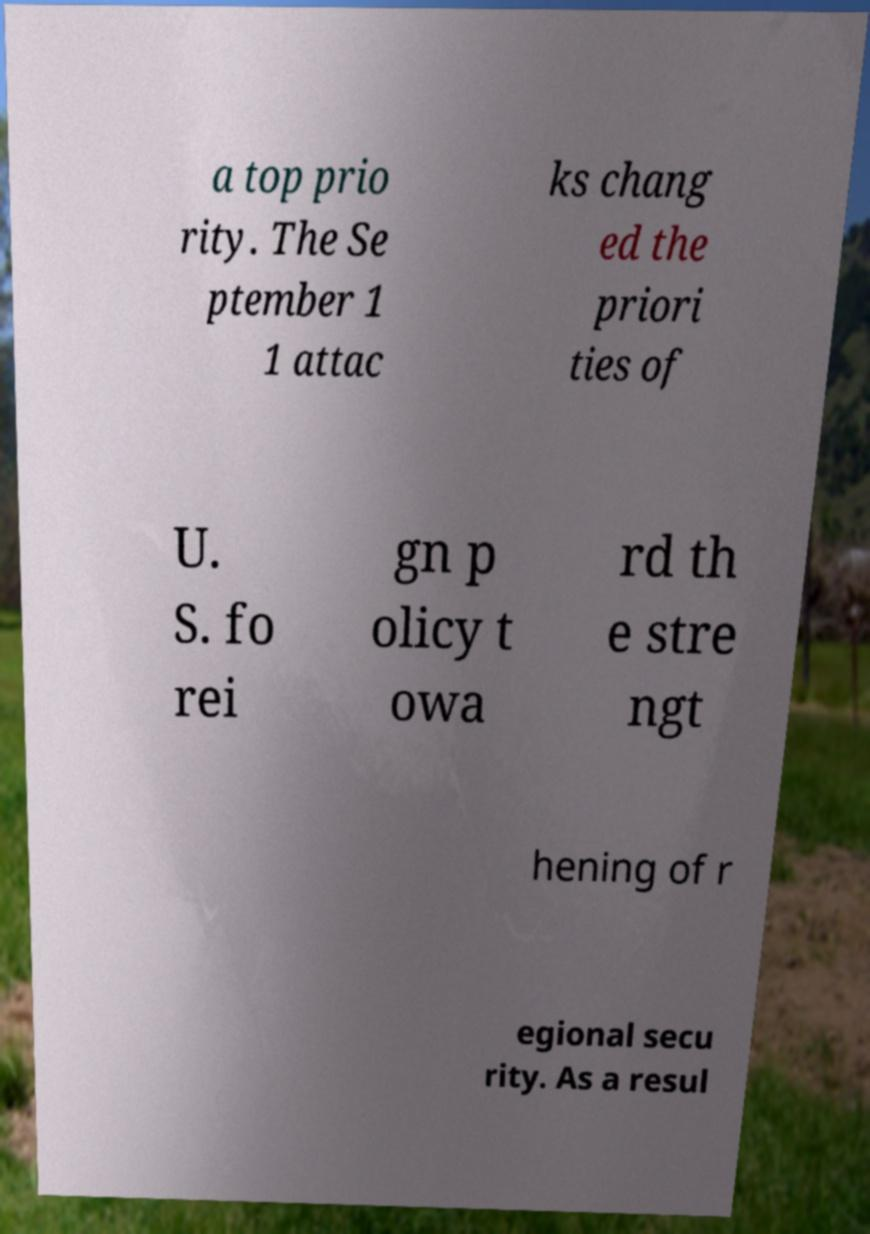Can you read and provide the text displayed in the image?This photo seems to have some interesting text. Can you extract and type it out for me? a top prio rity. The Se ptember 1 1 attac ks chang ed the priori ties of U. S. fo rei gn p olicy t owa rd th e stre ngt hening of r egional secu rity. As a resul 